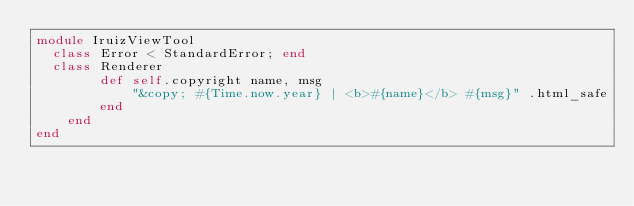Convert code to text. <code><loc_0><loc_0><loc_500><loc_500><_Ruby_>module IruizViewTool
  class Error < StandardError; end
  class Renderer 
		def self.copyright name, msg
			"&copy; #{Time.now.year} | <b>#{name}</b> #{msg}" .html_safe
		end
	end
end</code> 